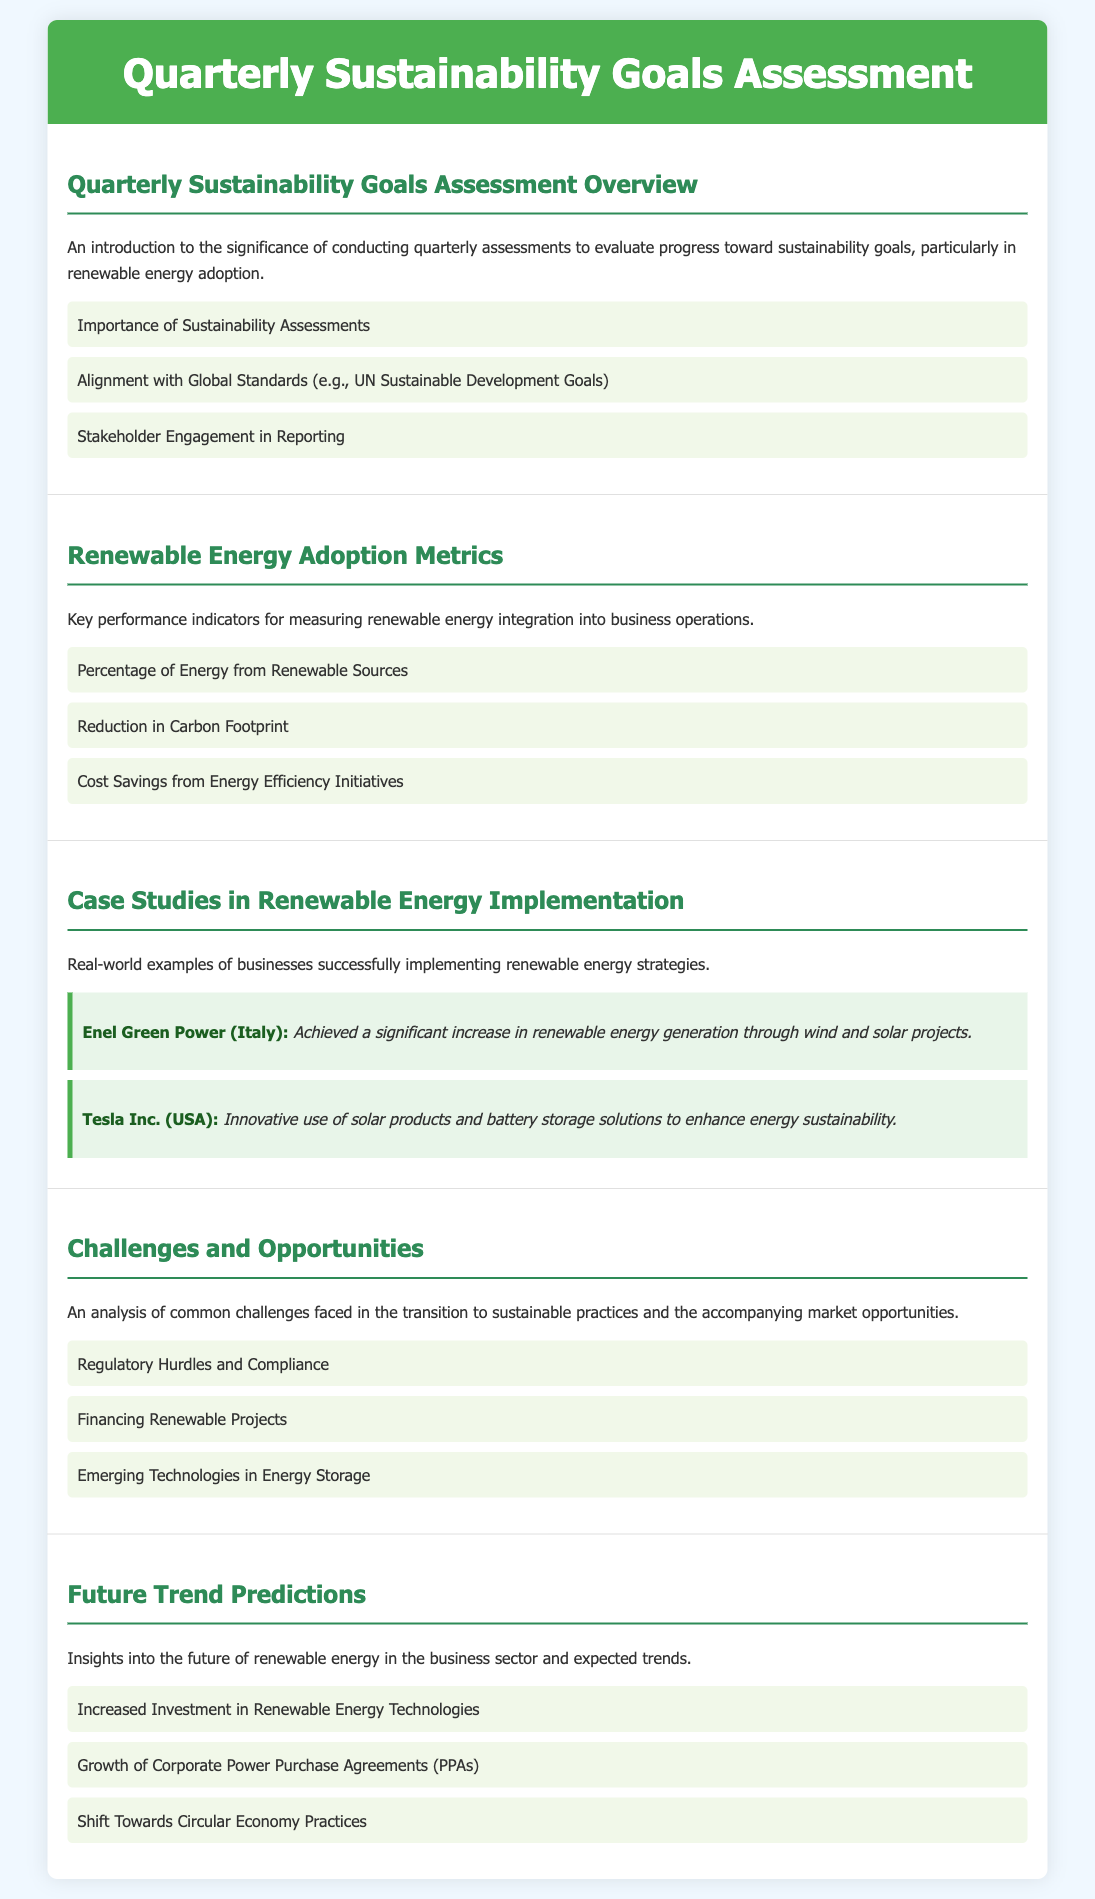What is the purpose of the quarterly sustainability goals assessment? The document introduces the significance of conducting quarterly assessments to evaluate progress toward sustainability goals, particularly in renewable energy adoption.
Answer: Evaluate progress What are some renewable energy adoption metrics? The document lists key performance indicators for measuring renewable energy integration into business operations.
Answer: Percentage of Energy from Renewable Sources Who is a case study example from Italy? The document provides a real-world example of a business, Enel Green Power, which successfully implements renewable energy strategies.
Answer: Enel Green Power What is one challenge mentioned regarding renewable energy practices? The document identifies common challenges faced in the transition to sustainable practices.
Answer: Regulatory Hurdles and Compliance What future trend is anticipated in the business sector regarding renewable energy? The document provides insights into future trends expected in the renewable energy sector.
Answer: Increased Investment in Renewable Energy Technologies What strategy did Tesla Inc. use to enhance energy sustainability? The document highlights innovative practices by Tesla Inc. involving solar products and battery storage solutions.
Answer: Solar products and battery storage solutions 